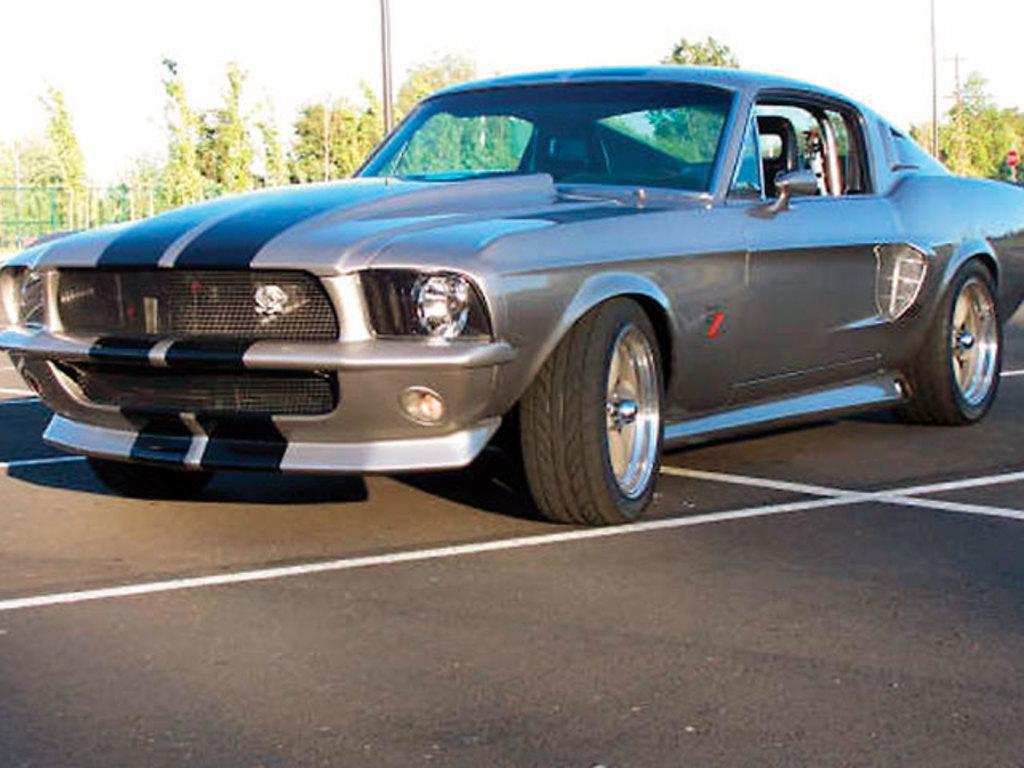What is the main subject of the image? There is a car on the road in the image. What can be seen in the background of the image? There are poles, trees, a fence, and the sky visible in the background of the image. Reasoning: Let's think step by identifying the main subject and objects in the image based on the provided facts. We then formulate questions that focus on the location and characteristics of these subjects and objects, ensuring that each question can be answered definitively with the information given. We avoid yes/no questions and ensure that the language is simple and clear. Absurd Question/Answer: What type of pot is being used to skate on the road in the image? There is no pot or skating activity present in the image. How many times does the car bite into the fence in the image? There is no biting or interaction between the car and the fence in the image. 